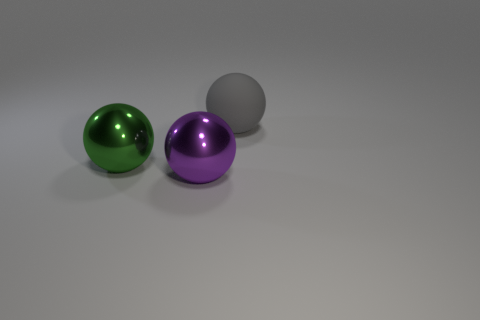Subtract all big green spheres. How many spheres are left? 2 Add 1 large purple metallic balls. How many objects exist? 4 Subtract all purple spheres. How many spheres are left? 2 Subtract all purple objects. Subtract all purple balls. How many objects are left? 1 Add 2 rubber spheres. How many rubber spheres are left? 3 Add 3 big matte balls. How many big matte balls exist? 4 Subtract 1 purple spheres. How many objects are left? 2 Subtract 1 spheres. How many spheres are left? 2 Subtract all purple balls. Subtract all red cylinders. How many balls are left? 2 Subtract all brown cylinders. How many red balls are left? 0 